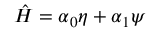<formula> <loc_0><loc_0><loc_500><loc_500>\hat { H } = \alpha _ { 0 } \eta + \alpha _ { 1 } \psi</formula> 